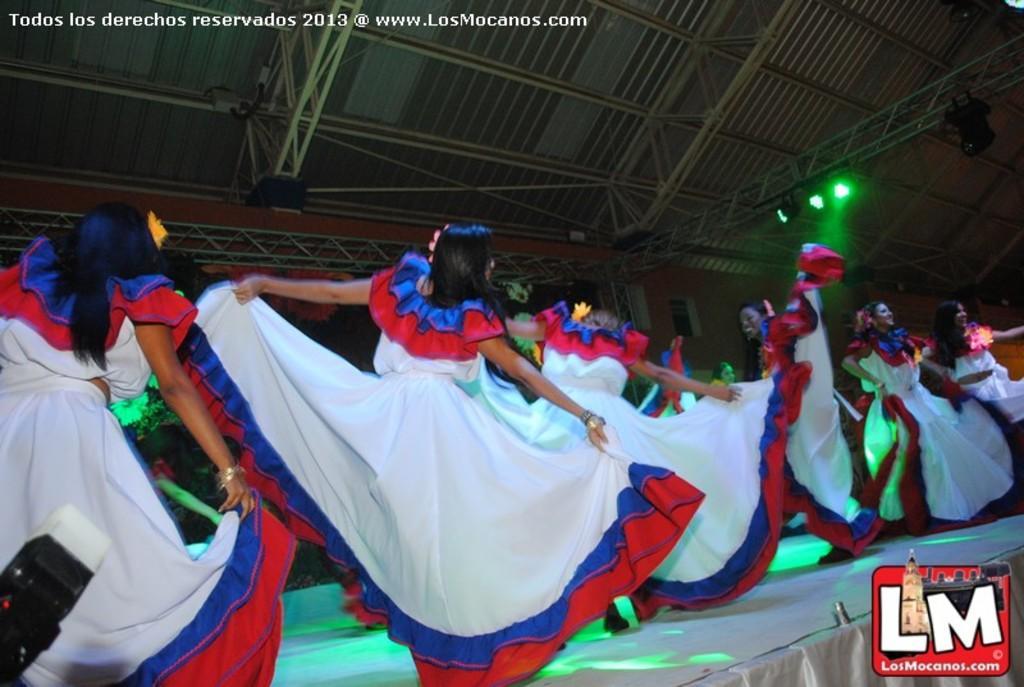Could you give a brief overview of what you see in this image? In this image I can see few women wearing white color frocks and dancing on the stage. At the top of the image there are few metal rods and also I can see some lights. In the bottom right there is a logo. 